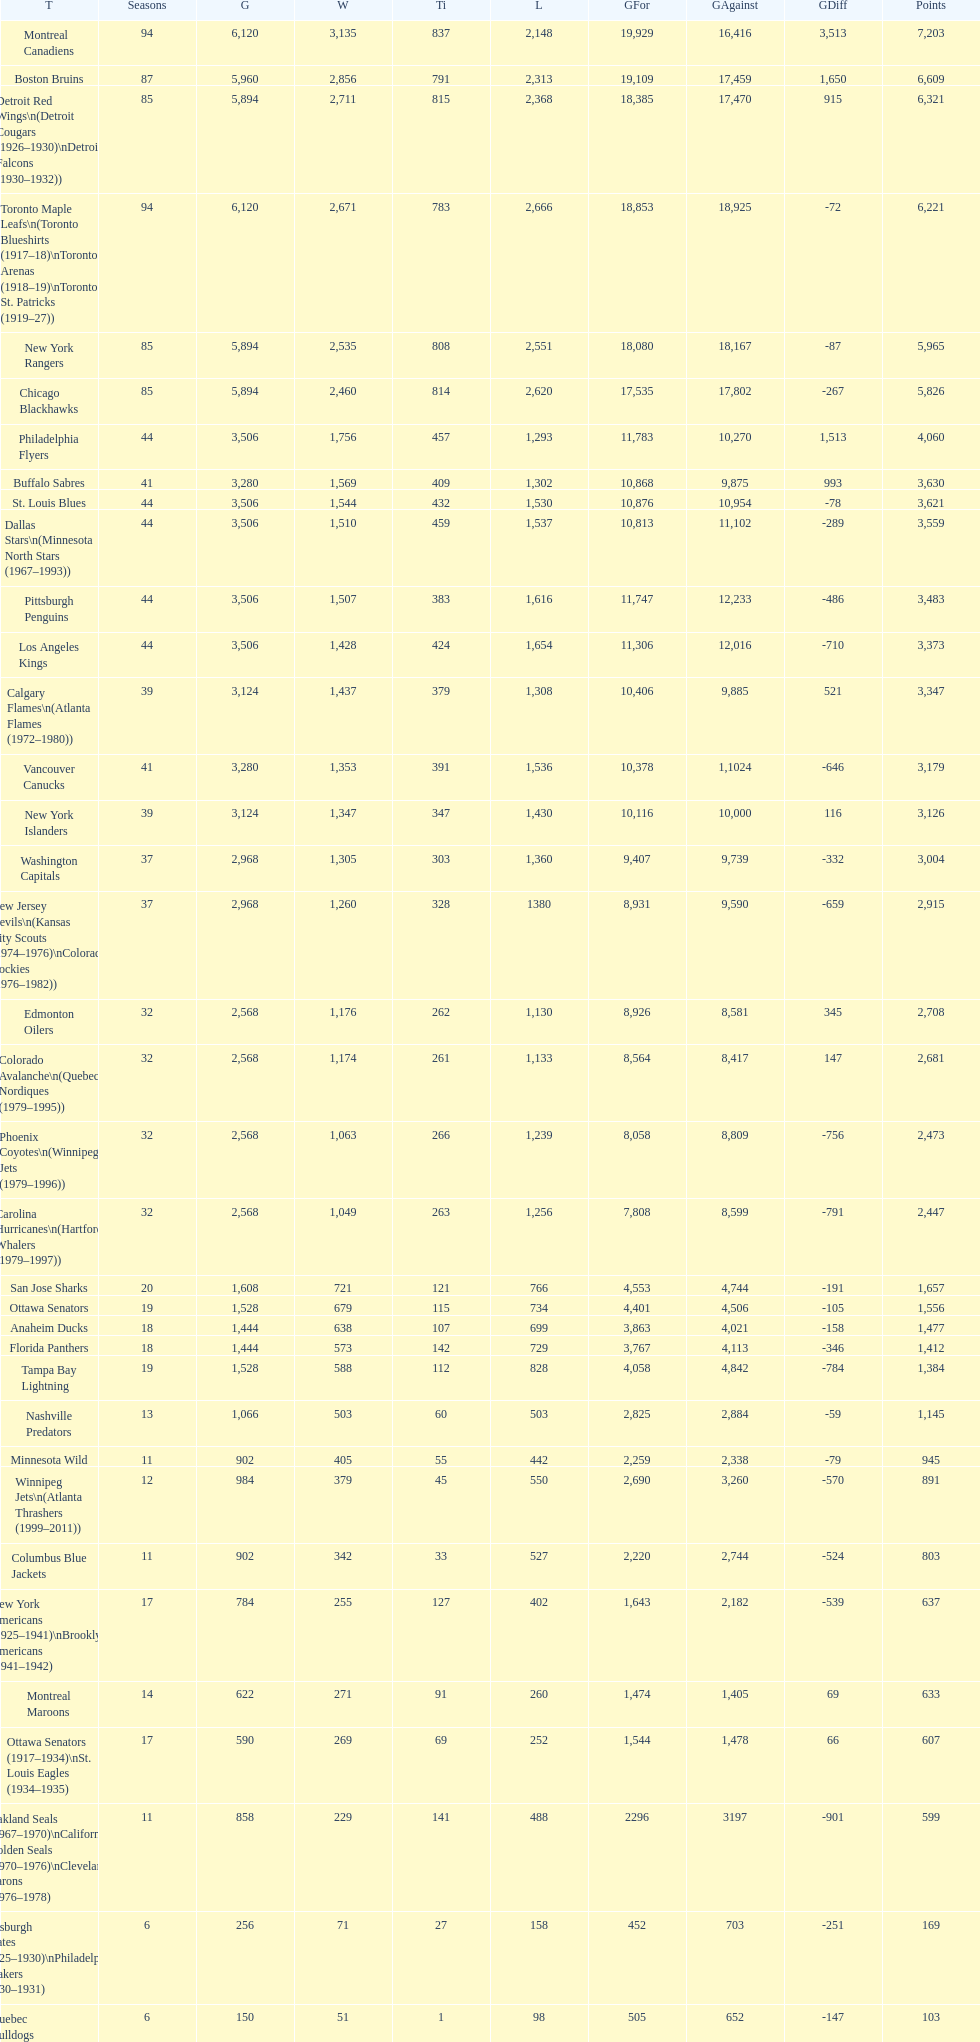Could you help me parse every detail presented in this table? {'header': ['T', 'Seasons', 'G', 'W', 'Ti', 'L', 'GFor', 'GAgainst', 'GDiff', 'Points'], 'rows': [['Montreal Canadiens', '94', '6,120', '3,135', '837', '2,148', '19,929', '16,416', '3,513', '7,203'], ['Boston Bruins', '87', '5,960', '2,856', '791', '2,313', '19,109', '17,459', '1,650', '6,609'], ['Detroit Red Wings\\n(Detroit Cougars (1926–1930)\\nDetroit Falcons (1930–1932))', '85', '5,894', '2,711', '815', '2,368', '18,385', '17,470', '915', '6,321'], ['Toronto Maple Leafs\\n(Toronto Blueshirts (1917–18)\\nToronto Arenas (1918–19)\\nToronto St. Patricks (1919–27))', '94', '6,120', '2,671', '783', '2,666', '18,853', '18,925', '-72', '6,221'], ['New York Rangers', '85', '5,894', '2,535', '808', '2,551', '18,080', '18,167', '-87', '5,965'], ['Chicago Blackhawks', '85', '5,894', '2,460', '814', '2,620', '17,535', '17,802', '-267', '5,826'], ['Philadelphia Flyers', '44', '3,506', '1,756', '457', '1,293', '11,783', '10,270', '1,513', '4,060'], ['Buffalo Sabres', '41', '3,280', '1,569', '409', '1,302', '10,868', '9,875', '993', '3,630'], ['St. Louis Blues', '44', '3,506', '1,544', '432', '1,530', '10,876', '10,954', '-78', '3,621'], ['Dallas Stars\\n(Minnesota North Stars (1967–1993))', '44', '3,506', '1,510', '459', '1,537', '10,813', '11,102', '-289', '3,559'], ['Pittsburgh Penguins', '44', '3,506', '1,507', '383', '1,616', '11,747', '12,233', '-486', '3,483'], ['Los Angeles Kings', '44', '3,506', '1,428', '424', '1,654', '11,306', '12,016', '-710', '3,373'], ['Calgary Flames\\n(Atlanta Flames (1972–1980))', '39', '3,124', '1,437', '379', '1,308', '10,406', '9,885', '521', '3,347'], ['Vancouver Canucks', '41', '3,280', '1,353', '391', '1,536', '10,378', '1,1024', '-646', '3,179'], ['New York Islanders', '39', '3,124', '1,347', '347', '1,430', '10,116', '10,000', '116', '3,126'], ['Washington Capitals', '37', '2,968', '1,305', '303', '1,360', '9,407', '9,739', '-332', '3,004'], ['New Jersey Devils\\n(Kansas City Scouts (1974–1976)\\nColorado Rockies (1976–1982))', '37', '2,968', '1,260', '328', '1380', '8,931', '9,590', '-659', '2,915'], ['Edmonton Oilers', '32', '2,568', '1,176', '262', '1,130', '8,926', '8,581', '345', '2,708'], ['Colorado Avalanche\\n(Quebec Nordiques (1979–1995))', '32', '2,568', '1,174', '261', '1,133', '8,564', '8,417', '147', '2,681'], ['Phoenix Coyotes\\n(Winnipeg Jets (1979–1996))', '32', '2,568', '1,063', '266', '1,239', '8,058', '8,809', '-756', '2,473'], ['Carolina Hurricanes\\n(Hartford Whalers (1979–1997))', '32', '2,568', '1,049', '263', '1,256', '7,808', '8,599', '-791', '2,447'], ['San Jose Sharks', '20', '1,608', '721', '121', '766', '4,553', '4,744', '-191', '1,657'], ['Ottawa Senators', '19', '1,528', '679', '115', '734', '4,401', '4,506', '-105', '1,556'], ['Anaheim Ducks', '18', '1,444', '638', '107', '699', '3,863', '4,021', '-158', '1,477'], ['Florida Panthers', '18', '1,444', '573', '142', '729', '3,767', '4,113', '-346', '1,412'], ['Tampa Bay Lightning', '19', '1,528', '588', '112', '828', '4,058', '4,842', '-784', '1,384'], ['Nashville Predators', '13', '1,066', '503', '60', '503', '2,825', '2,884', '-59', '1,145'], ['Minnesota Wild', '11', '902', '405', '55', '442', '2,259', '2,338', '-79', '945'], ['Winnipeg Jets\\n(Atlanta Thrashers (1999–2011))', '12', '984', '379', '45', '550', '2,690', '3,260', '-570', '891'], ['Columbus Blue Jackets', '11', '902', '342', '33', '527', '2,220', '2,744', '-524', '803'], ['New York Americans (1925–1941)\\nBrooklyn Americans (1941–1942)', '17', '784', '255', '127', '402', '1,643', '2,182', '-539', '637'], ['Montreal Maroons', '14', '622', '271', '91', '260', '1,474', '1,405', '69', '633'], ['Ottawa Senators (1917–1934)\\nSt. Louis Eagles (1934–1935)', '17', '590', '269', '69', '252', '1,544', '1,478', '66', '607'], ['Oakland Seals (1967–1970)\\nCalifornia Golden Seals (1970–1976)\\nCleveland Barons (1976–1978)', '11', '858', '229', '141', '488', '2296', '3197', '-901', '599'], ['Pittsburgh Pirates (1925–1930)\\nPhiladelphia Quakers (1930–1931)', '6', '256', '71', '27', '158', '452', '703', '-251', '169'], ['Quebec Bulldogs (1919–1920)\\nHamilton Tigers (1920–1925)', '6', '150', '51', '1', '98', '505', '652', '-147', '103'], ['Montreal Wanderers', '1', '6', '1', '0', '5', '17', '35', '-18', '2']]} Which team played the same amount of seasons as the canadiens? Toronto Maple Leafs. 